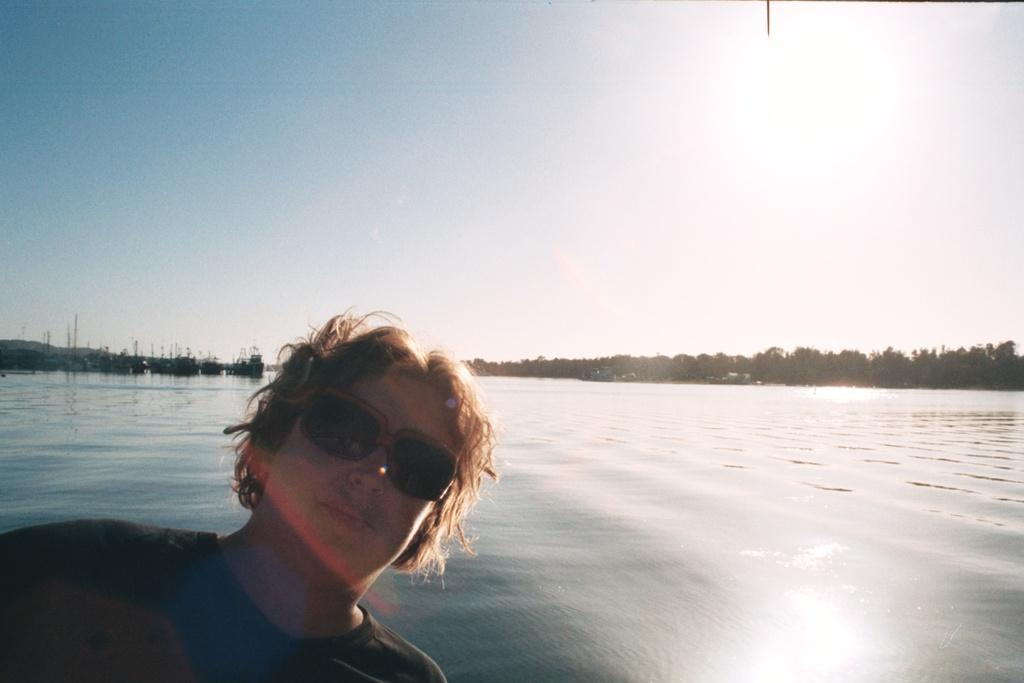What can be seen on the person in the image? There is a person with spectacles in the image. What is on the water in the image? There are boats on the water in the image. What type of vegetation is present in the image? There are trees in the image. What type of landscape feature can be seen in the image? There are hills in the image. What is visible in the background of the image? The sky is visible in the background of the image. What type of prison can be seen in the image? There is no prison present in the image. What is the person's desire in the image? The image does not provide information about the person's desires. 